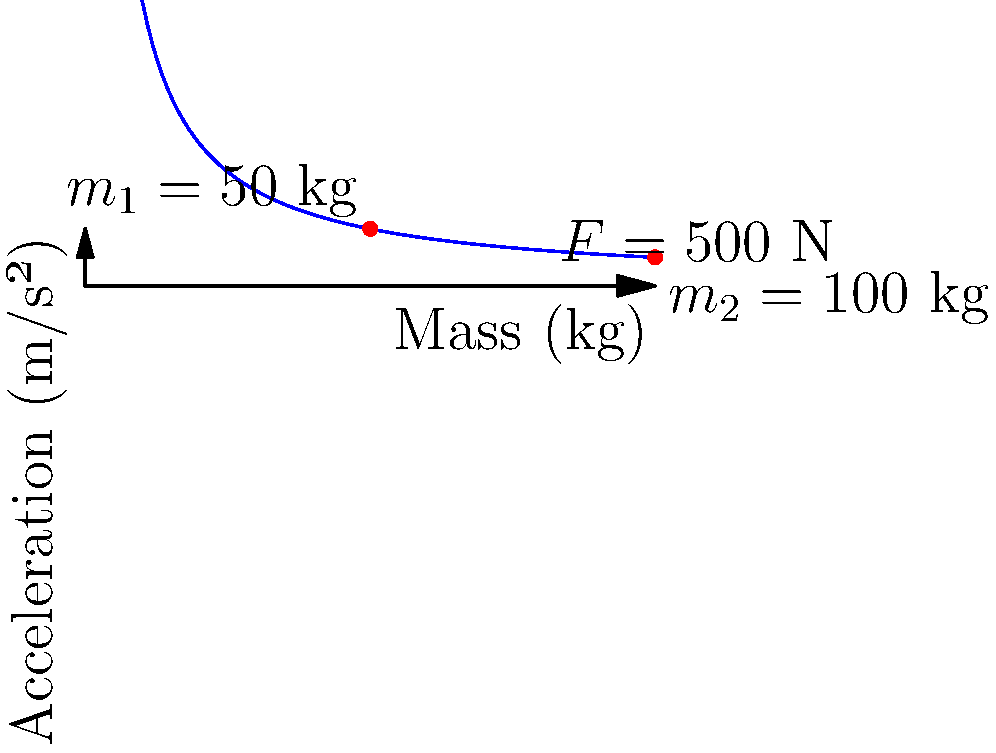In a soccer match, two players collide with each other. Player 1 has a mass of 50 kg, while Player 2 has a mass of 100 kg. The graph shows the relationship between mass and acceleration for a constant force of 500 N. Based on this information, determine the difference in acceleration experienced by the two players during the collision. To solve this problem, we'll use Newton's Second Law of Motion: $F = ma$, where $F$ is the force, $m$ is the mass, and $a$ is the acceleration.

Given:
- Constant force $F = 500$ N
- Mass of Player 1: $m_1 = 50$ kg
- Mass of Player 2: $m_2 = 100$ kg

Step 1: Calculate the acceleration for Player 1
$a_1 = \frac{F}{m_1} = \frac{500 \text{ N}}{50 \text{ kg}} = 10 \text{ m/s²}$

Step 2: Calculate the acceleration for Player 2
$a_2 = \frac{F}{m_2} = \frac{500 \text{ N}}{100 \text{ kg}} = 5 \text{ m/s²}$

Step 3: Calculate the difference in acceleration
$\Delta a = a_1 - a_2 = 10 \text{ m/s²} - 5 \text{ m/s²} = 5 \text{ m/s²}$

Therefore, the difference in acceleration experienced by the two players during the collision is 5 m/s².
Answer: 5 m/s² 